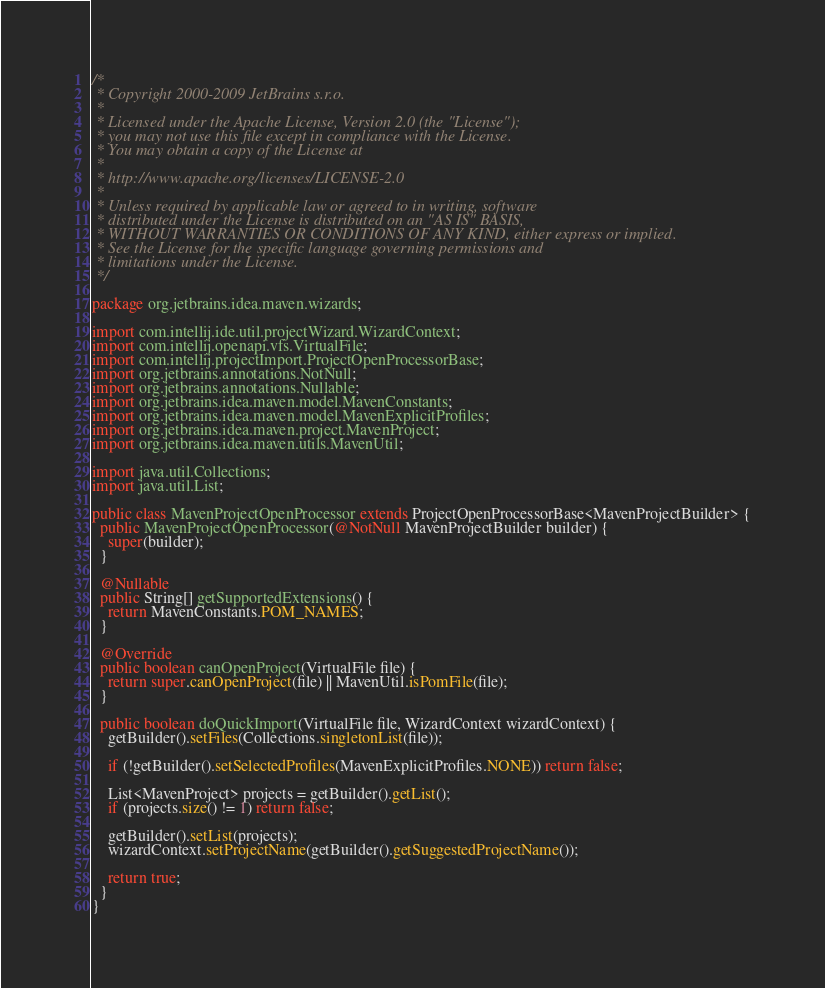<code> <loc_0><loc_0><loc_500><loc_500><_Java_>/*
 * Copyright 2000-2009 JetBrains s.r.o.
 *
 * Licensed under the Apache License, Version 2.0 (the "License");
 * you may not use this file except in compliance with the License.
 * You may obtain a copy of the License at
 *
 * http://www.apache.org/licenses/LICENSE-2.0
 *
 * Unless required by applicable law or agreed to in writing, software
 * distributed under the License is distributed on an "AS IS" BASIS,
 * WITHOUT WARRANTIES OR CONDITIONS OF ANY KIND, either express or implied.
 * See the License for the specific language governing permissions and
 * limitations under the License.
 */

package org.jetbrains.idea.maven.wizards;

import com.intellij.ide.util.projectWizard.WizardContext;
import com.intellij.openapi.vfs.VirtualFile;
import com.intellij.projectImport.ProjectOpenProcessorBase;
import org.jetbrains.annotations.NotNull;
import org.jetbrains.annotations.Nullable;
import org.jetbrains.idea.maven.model.MavenConstants;
import org.jetbrains.idea.maven.model.MavenExplicitProfiles;
import org.jetbrains.idea.maven.project.MavenProject;
import org.jetbrains.idea.maven.utils.MavenUtil;

import java.util.Collections;
import java.util.List;

public class MavenProjectOpenProcessor extends ProjectOpenProcessorBase<MavenProjectBuilder> {
  public MavenProjectOpenProcessor(@NotNull MavenProjectBuilder builder) {
    super(builder);
  }

  @Nullable
  public String[] getSupportedExtensions() {
    return MavenConstants.POM_NAMES;
  }

  @Override
  public boolean canOpenProject(VirtualFile file) {
    return super.canOpenProject(file) || MavenUtil.isPomFile(file);
  }

  public boolean doQuickImport(VirtualFile file, WizardContext wizardContext) {
    getBuilder().setFiles(Collections.singletonList(file));

    if (!getBuilder().setSelectedProfiles(MavenExplicitProfiles.NONE)) return false;

    List<MavenProject> projects = getBuilder().getList();
    if (projects.size() != 1) return false;

    getBuilder().setList(projects);
    wizardContext.setProjectName(getBuilder().getSuggestedProjectName());

    return true;
  }
}
</code> 